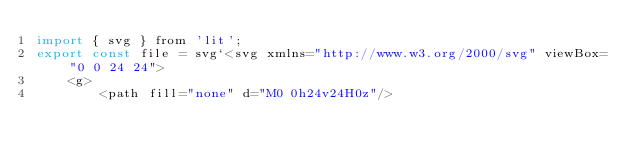<code> <loc_0><loc_0><loc_500><loc_500><_JavaScript_>import { svg } from 'lit';
export const file = svg`<svg xmlns="http://www.w3.org/2000/svg" viewBox="0 0 24 24">
    <g>
        <path fill="none" d="M0 0h24v24H0z"/></code> 